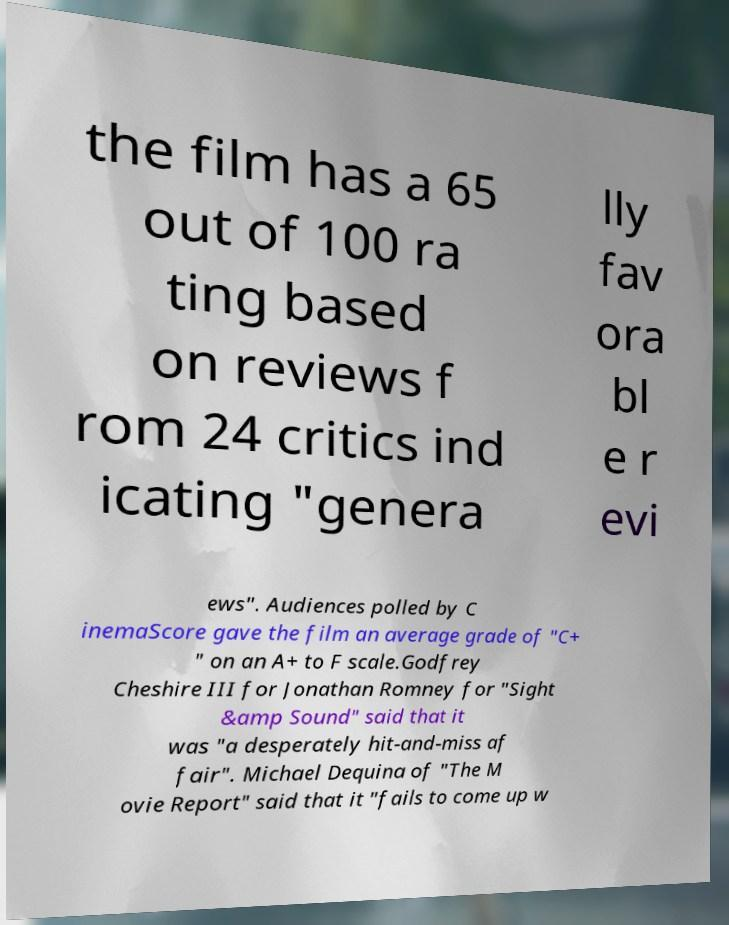Can you accurately transcribe the text from the provided image for me? the film has a 65 out of 100 ra ting based on reviews f rom 24 critics ind icating "genera lly fav ora bl e r evi ews". Audiences polled by C inemaScore gave the film an average grade of "C+ " on an A+ to F scale.Godfrey Cheshire III for Jonathan Romney for "Sight &amp Sound" said that it was "a desperately hit-and-miss af fair". Michael Dequina of "The M ovie Report" said that it "fails to come up w 